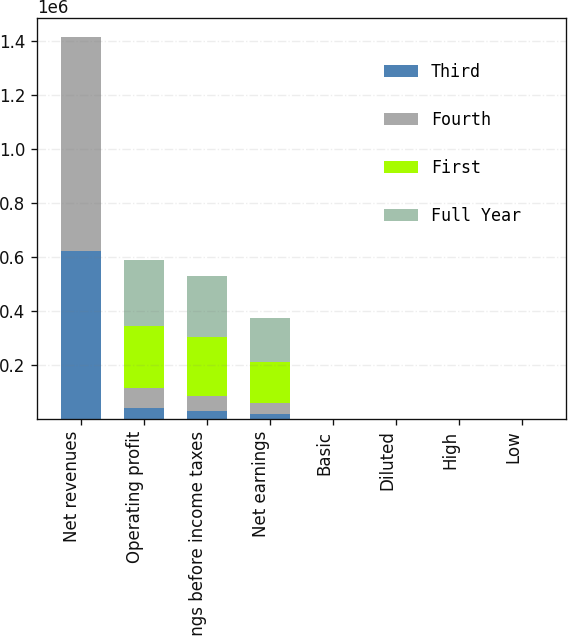Convert chart. <chart><loc_0><loc_0><loc_500><loc_500><stacked_bar_chart><ecel><fcel>Net revenues<fcel>Operating profit<fcel>Earnings before income taxes<fcel>Net earnings<fcel>Basic<fcel>Diluted<fcel>High<fcel>Low<nl><fcel>Third<fcel>621340<fcel>41217<fcel>28587<fcel>19730<fcel>0.14<fcel>0.14<fcel>29.91<fcel>21.14<nl><fcel>Fourth<fcel>792202<fcel>73073<fcel>56854<fcel>39275<fcel>0.28<fcel>0.26<fcel>29.23<fcel>22.27<nl><fcel>First<fcel>31.19<fcel>230709<fcel>217859<fcel>150362<fcel>1.08<fcel>0.99<fcel>29.36<fcel>22.79<nl><fcel>Full Year<fcel>31.19<fcel>243599<fcel>226397<fcel>165563<fcel>1.2<fcel>1.09<fcel>32.47<fcel>26.82<nl></chart> 